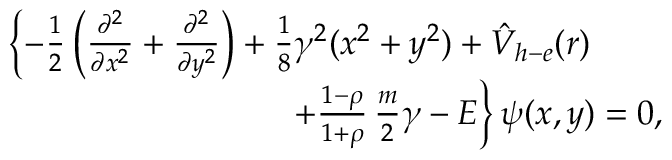<formula> <loc_0><loc_0><loc_500><loc_500>\begin{array} { r } { \left \{ - \frac { 1 } { 2 } \left ( \frac { \partial ^ { 2 } } { \partial x ^ { 2 } } + \frac { \partial ^ { 2 } } { \partial y ^ { 2 } } \right ) + \frac { 1 } { 8 } \gamma ^ { 2 } ( x ^ { 2 } + y ^ { 2 } ) + { \hat { V } } _ { h - e } ( r ) \quad } \\ { \quad + \frac { 1 - \rho } { 1 + \rho } \, \frac { m } { 2 } \gamma - E \right \} \psi ( x , y ) = 0 , } \end{array}</formula> 